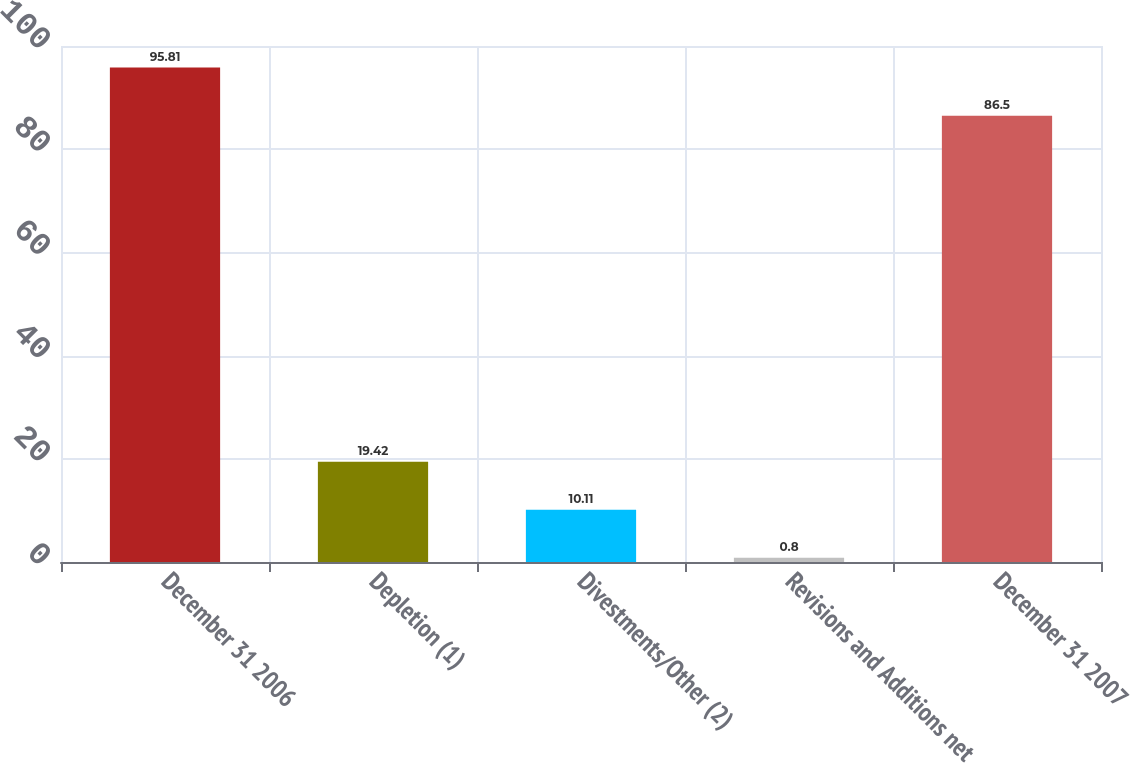Convert chart to OTSL. <chart><loc_0><loc_0><loc_500><loc_500><bar_chart><fcel>December 31 2006<fcel>Depletion (1)<fcel>Divestments/Other (2)<fcel>Revisions and Additions net<fcel>December 31 2007<nl><fcel>95.81<fcel>19.42<fcel>10.11<fcel>0.8<fcel>86.5<nl></chart> 